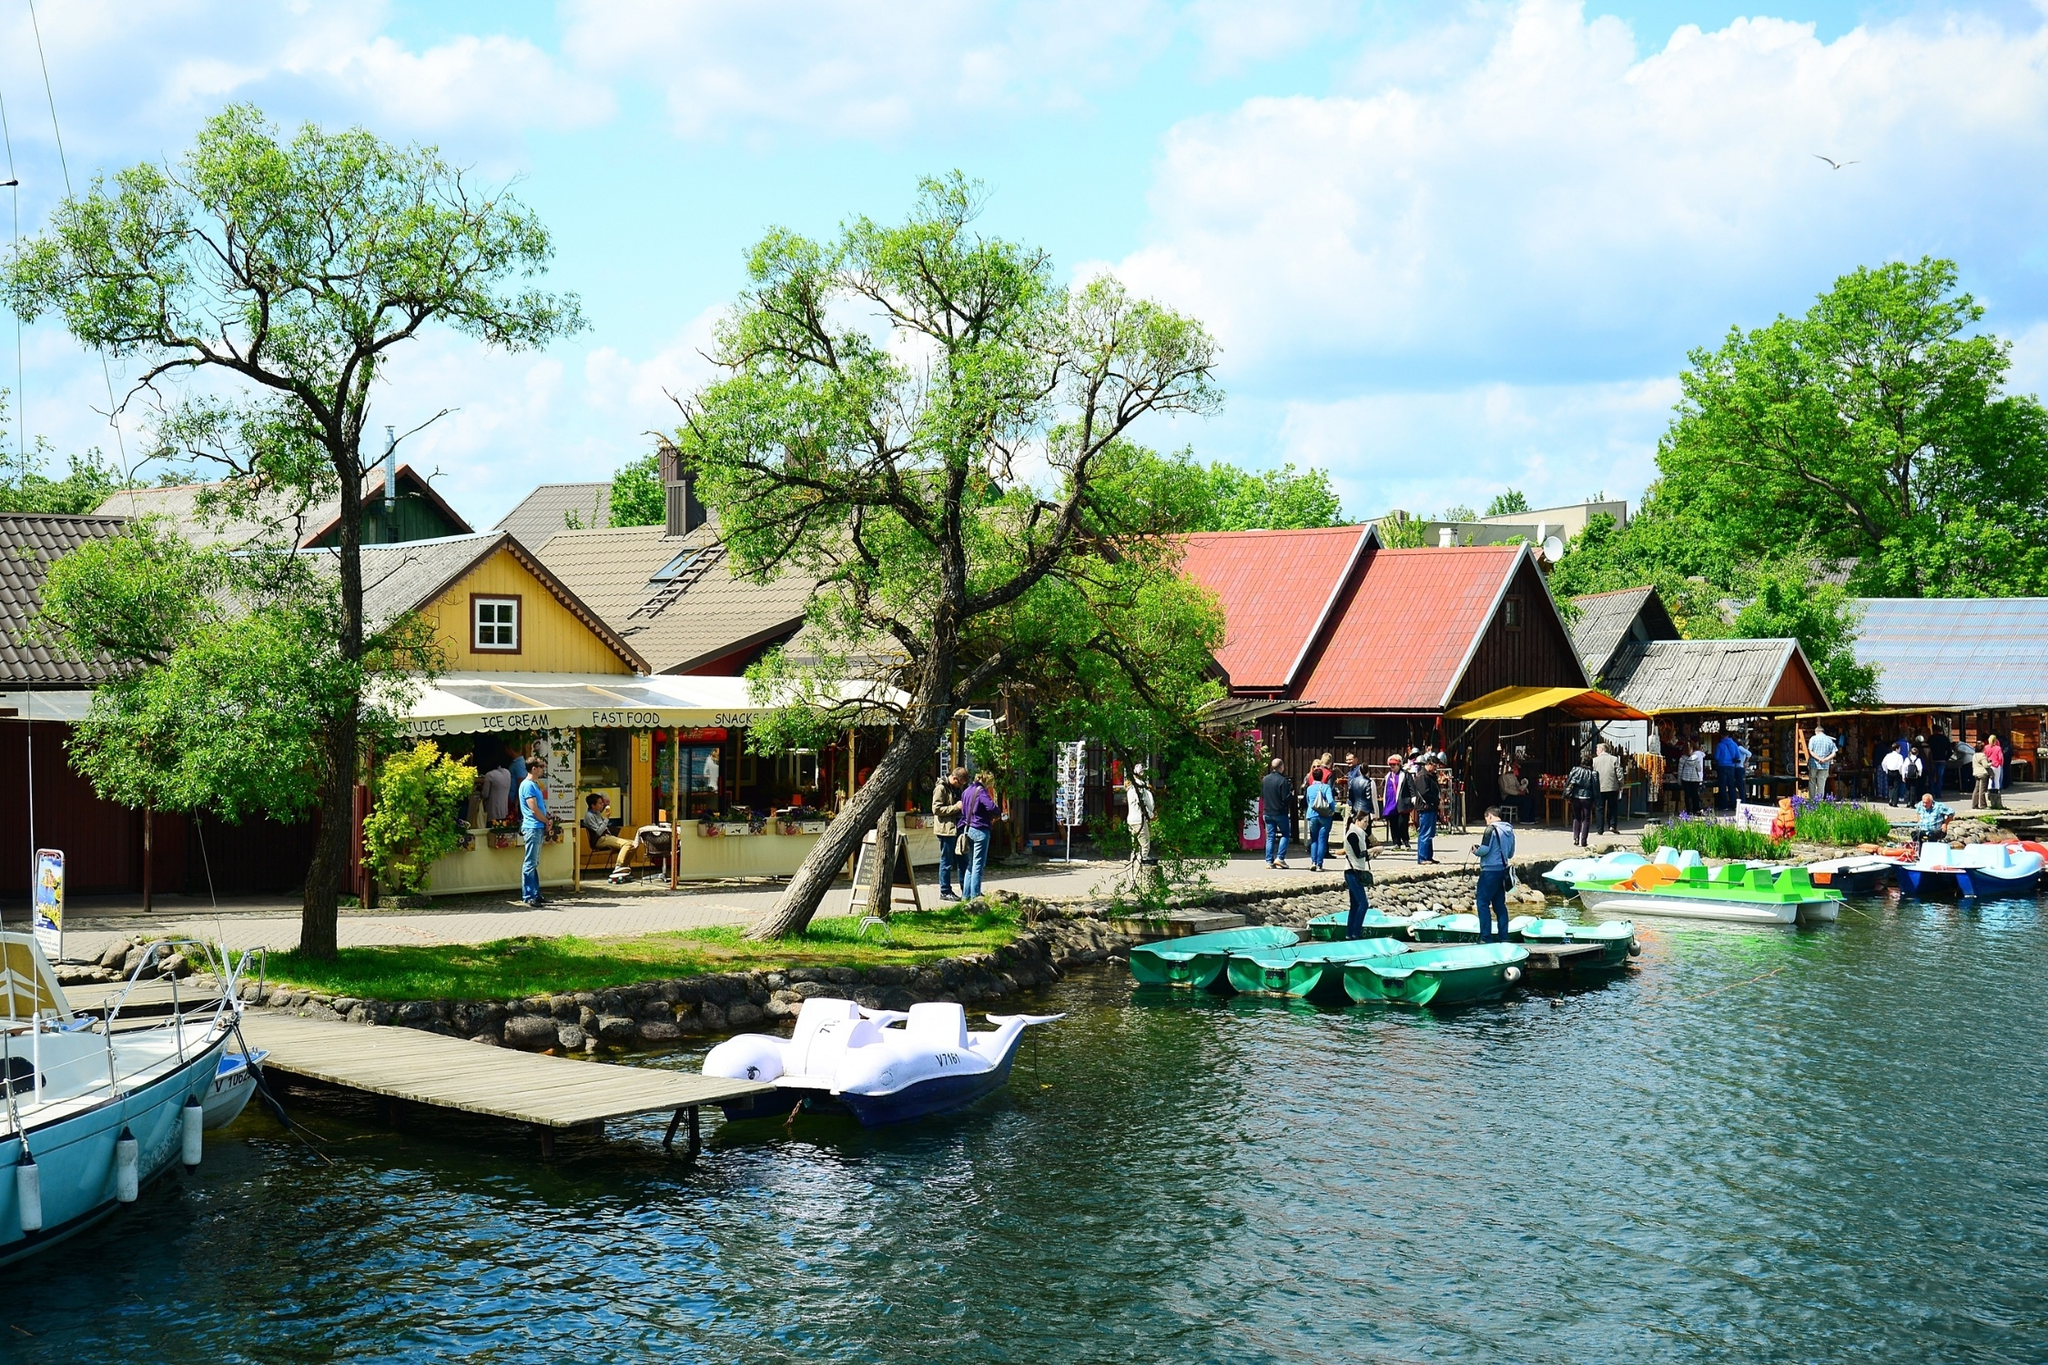Imagine this village at night. Describe the scene. As night falls, the village transforms into a serene and magical setting. The houses with their red and yellow roofs are softly illuminated by warm, glowing lights from within. The kiosks, which were bustling with activity during the day, are now closed, their shutters down but still exuding a cozy charm. The dock and paddle boats reflect the moonlight shimmering on the lake's surface, creating a tranquil and picturesque scene. A few street lamps cast a gentle glow on the pathways, and the clear night sky is dotted with twinkling stars. The peaceful ambiance encourages quiet strolls and intimate conversations, capturing the essence of a serene lakeside night. 